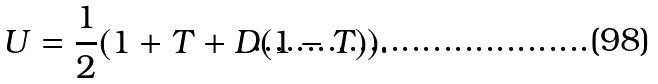<formula> <loc_0><loc_0><loc_500><loc_500>U = \frac { 1 } { 2 } ( 1 + T + D ( 1 - T ) ) .</formula> 